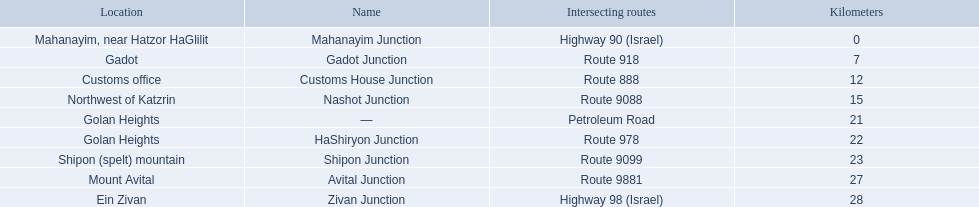Which junctions are located on numbered routes, and not highways or other types? Gadot Junction, Customs House Junction, Nashot Junction, HaShiryon Junction, Shipon Junction, Avital Junction. Of these junctions, which ones are located on routes with four digits (ex. route 9999)? Nashot Junction, Shipon Junction, Avital Junction. Of the remaining routes, which is located on shipon (spelt) mountain? Shipon Junction. 